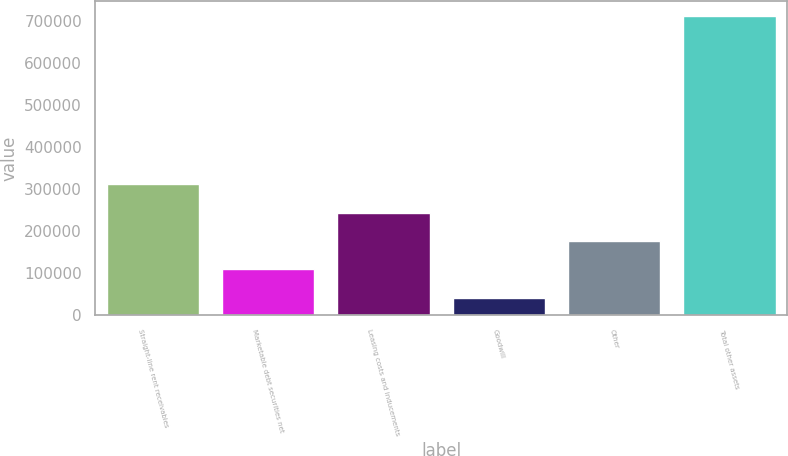Convert chart. <chart><loc_0><loc_0><loc_500><loc_500><bar_chart><fcel>Straight-line rent receivables<fcel>Marketable debt securities net<fcel>Leasing costs and inducements<fcel>Goodwill<fcel>Other<fcel>Total other assets<nl><fcel>311776<fcel>109310<fcel>243157<fcel>42386<fcel>176234<fcel>711624<nl></chart> 